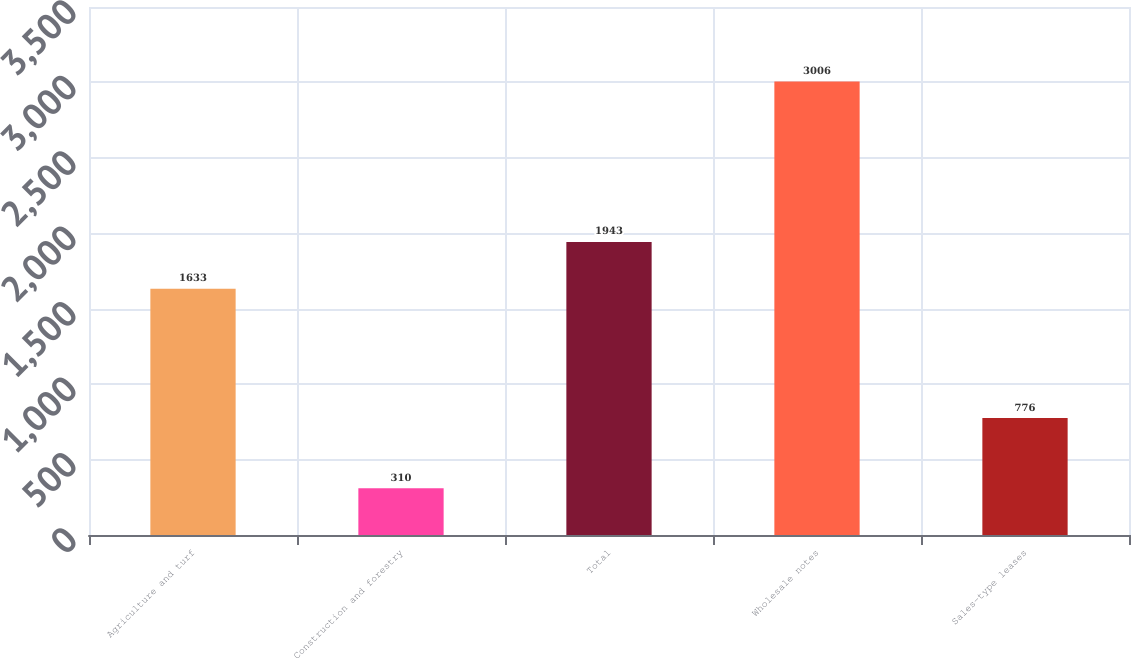<chart> <loc_0><loc_0><loc_500><loc_500><bar_chart><fcel>Agriculture and turf<fcel>Construction and forestry<fcel>Total<fcel>Wholesale notes<fcel>Sales-type leases<nl><fcel>1633<fcel>310<fcel>1943<fcel>3006<fcel>776<nl></chart> 